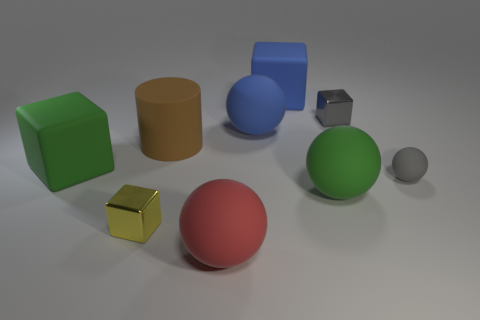Subtract 1 balls. How many balls are left? 3 Subtract all red cubes. Subtract all blue cylinders. How many cubes are left? 4 Subtract all cubes. How many objects are left? 5 Add 7 red objects. How many red objects are left? 8 Add 2 small gray balls. How many small gray balls exist? 3 Subtract 1 yellow cubes. How many objects are left? 8 Subtract all tiny gray rubber things. Subtract all tiny matte cylinders. How many objects are left? 8 